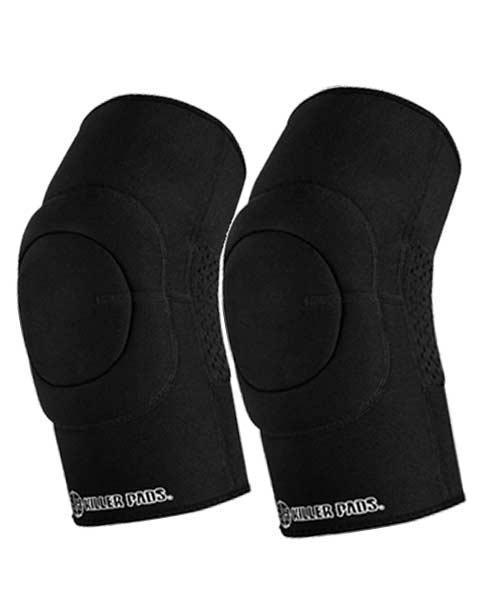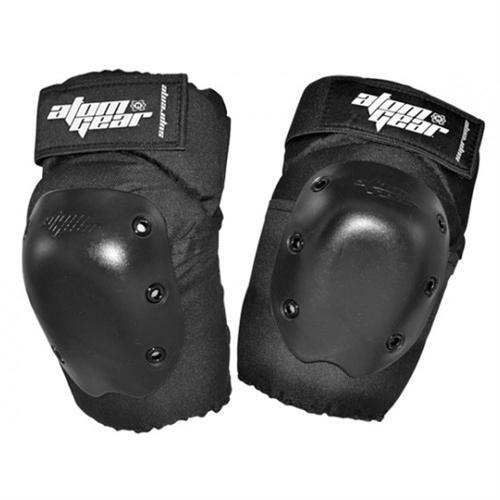The first image is the image on the left, the second image is the image on the right. For the images displayed, is the sentence "The left image shows at least one pair of knee caps that are being worn on a person's legs" factually correct? Answer yes or no. No. The first image is the image on the left, the second image is the image on the right. Given the left and right images, does the statement "An image includes a pair of human legs wearing black knee-pads." hold true? Answer yes or no. No. 